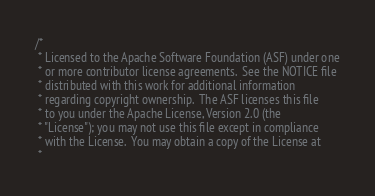<code> <loc_0><loc_0><loc_500><loc_500><_Scala_>/*
 * Licensed to the Apache Software Foundation (ASF) under one
 * or more contributor license agreements.  See the NOTICE file
 * distributed with this work for additional information
 * regarding copyright ownership.  The ASF licenses this file
 * to you under the Apache License, Version 2.0 (the
 * "License"); you may not use this file except in compliance
 * with the License.  You may obtain a copy of the License at
 *</code> 